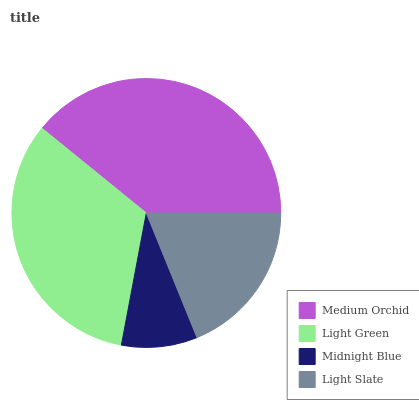Is Midnight Blue the minimum?
Answer yes or no. Yes. Is Medium Orchid the maximum?
Answer yes or no. Yes. Is Light Green the minimum?
Answer yes or no. No. Is Light Green the maximum?
Answer yes or no. No. Is Medium Orchid greater than Light Green?
Answer yes or no. Yes. Is Light Green less than Medium Orchid?
Answer yes or no. Yes. Is Light Green greater than Medium Orchid?
Answer yes or no. No. Is Medium Orchid less than Light Green?
Answer yes or no. No. Is Light Green the high median?
Answer yes or no. Yes. Is Light Slate the low median?
Answer yes or no. Yes. Is Light Slate the high median?
Answer yes or no. No. Is Light Green the low median?
Answer yes or no. No. 